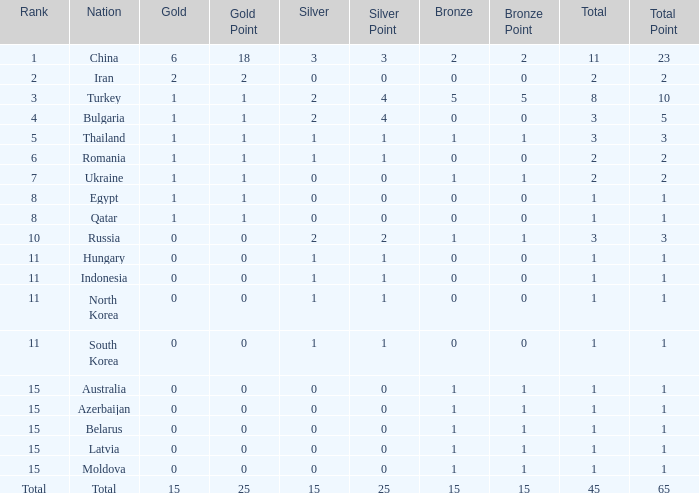What is the highest amount of bronze china, which has more than 1 gold and more than 11 total, has? None. 